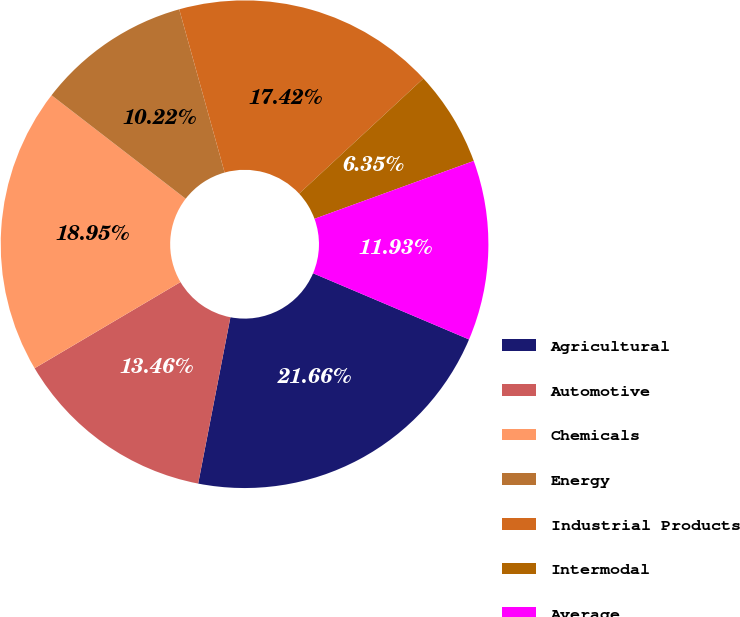Convert chart to OTSL. <chart><loc_0><loc_0><loc_500><loc_500><pie_chart><fcel>Agricultural<fcel>Automotive<fcel>Chemicals<fcel>Energy<fcel>Industrial Products<fcel>Intermodal<fcel>Average<nl><fcel>21.66%<fcel>13.46%<fcel>18.95%<fcel>10.22%<fcel>17.42%<fcel>6.35%<fcel>11.93%<nl></chart> 